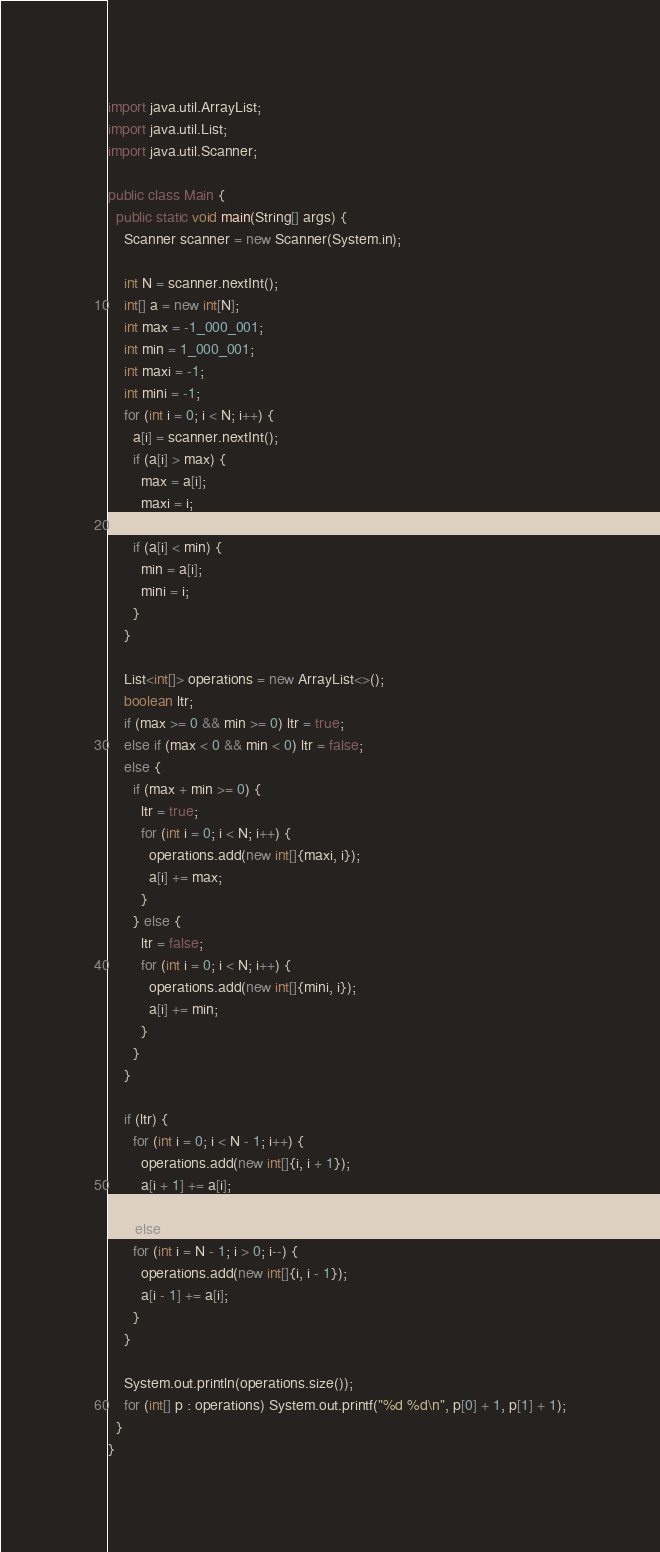Convert code to text. <code><loc_0><loc_0><loc_500><loc_500><_Java_>import java.util.ArrayList;
import java.util.List;
import java.util.Scanner;

public class Main {
  public static void main(String[] args) {
    Scanner scanner = new Scanner(System.in);

    int N = scanner.nextInt();
    int[] a = new int[N];
    int max = -1_000_001;
    int min = 1_000_001;
    int maxi = -1;
    int mini = -1;
    for (int i = 0; i < N; i++) {
      a[i] = scanner.nextInt();
      if (a[i] > max) {
        max = a[i];
        maxi = i;
      }
      if (a[i] < min) {
        min = a[i];
        mini = i;
      }
    }

    List<int[]> operations = new ArrayList<>();
    boolean ltr;
    if (max >= 0 && min >= 0) ltr = true;
    else if (max < 0 && min < 0) ltr = false;
    else {
      if (max + min >= 0) {
        ltr = true;
        for (int i = 0; i < N; i++) {
          operations.add(new int[]{maxi, i});
          a[i] += max;
        }
      } else {
        ltr = false;
        for (int i = 0; i < N; i++) {
          operations.add(new int[]{mini, i});
          a[i] += min;
        }
      }
    }

    if (ltr) {
      for (int i = 0; i < N - 1; i++) {
        operations.add(new int[]{i, i + 1});
        a[i + 1] += a[i];
      }
    } else {
      for (int i = N - 1; i > 0; i--) {
        operations.add(new int[]{i, i - 1});
        a[i - 1] += a[i];
      }
    }

    System.out.println(operations.size());
    for (int[] p : operations) System.out.printf("%d %d\n", p[0] + 1, p[1] + 1);
  }
}
</code> 